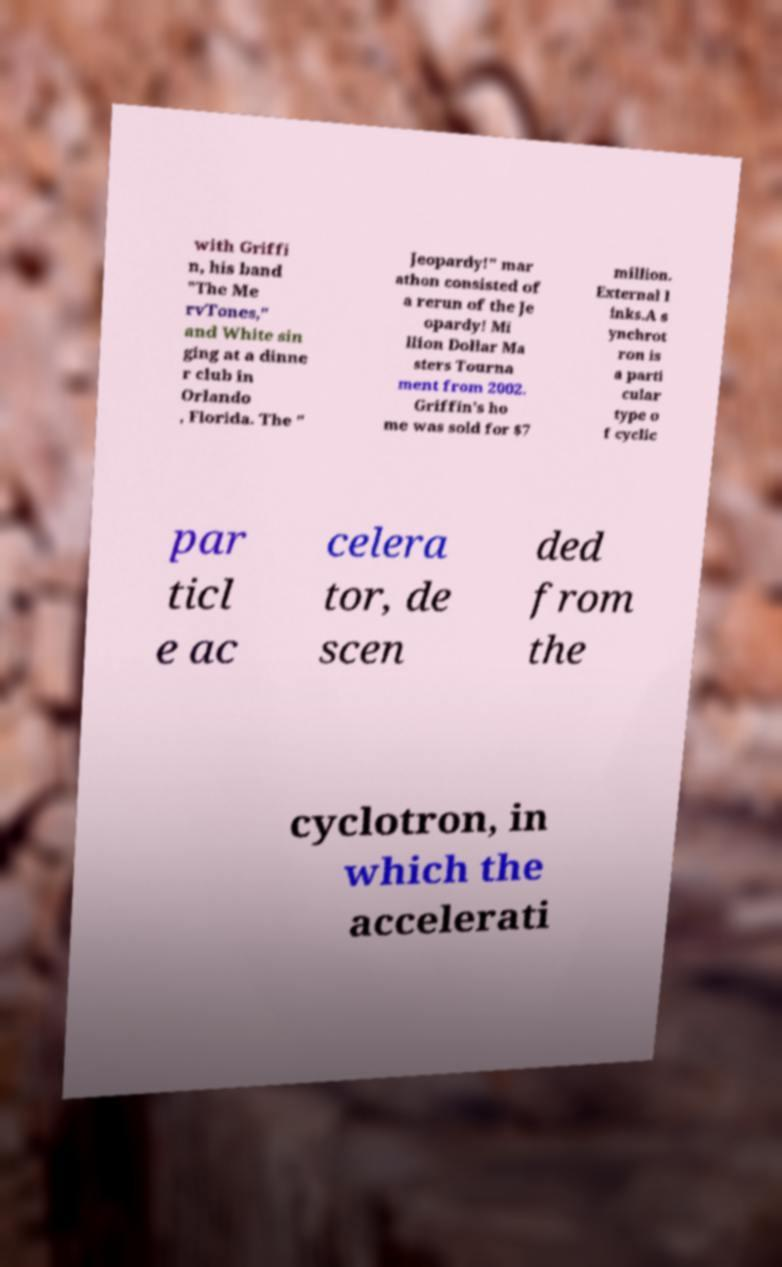For documentation purposes, I need the text within this image transcribed. Could you provide that? with Griffi n, his band "The Me rvTones," and White sin ging at a dinne r club in Orlando , Florida. The " Jeopardy!" mar athon consisted of a rerun of the Je opardy! Mi llion Dollar Ma sters Tourna ment from 2002. Griffin's ho me was sold for $7 million. External l inks.A s ynchrot ron is a parti cular type o f cyclic par ticl e ac celera tor, de scen ded from the cyclotron, in which the accelerati 